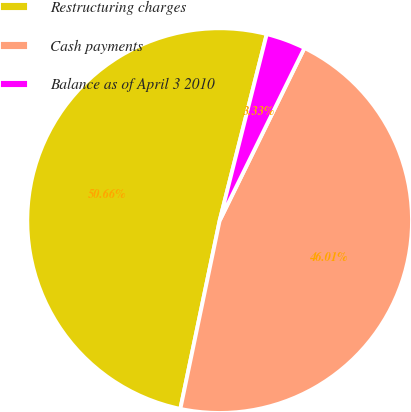Convert chart. <chart><loc_0><loc_0><loc_500><loc_500><pie_chart><fcel>Restructuring charges<fcel>Cash payments<fcel>Balance as of April 3 2010<nl><fcel>50.66%<fcel>46.01%<fcel>3.33%<nl></chart> 